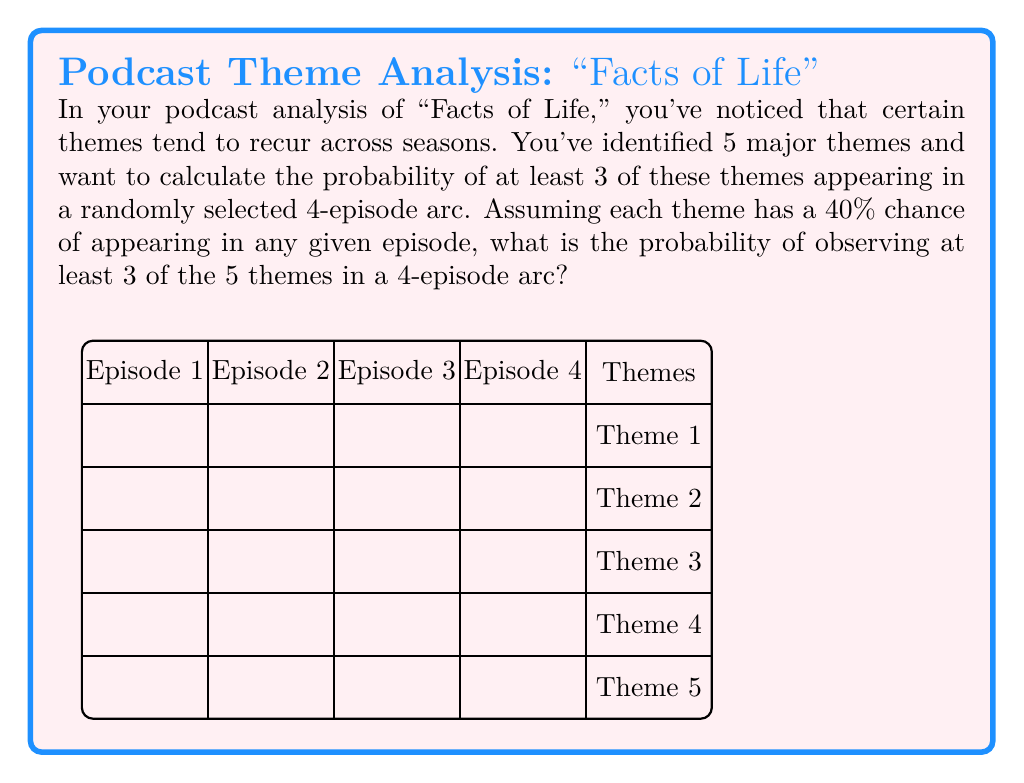Solve this math problem. Let's approach this step-by-step:

1) First, we need to calculate the probability of a single theme appearing in the 4-episode arc. The probability of a theme not appearing in an episode is 60% (1 - 40% = 60% or 0.6).

2) For a theme to not appear in the entire 4-episode arc, it must not appear in any of the 4 episodes. This probability is:

   $$(0.6)^4 = 0.1296$$

3) Therefore, the probability of a theme appearing at least once in the 4-episode arc is:

   $$1 - (0.6)^4 = 1 - 0.1296 = 0.8704$$

4) Now, we can use the binomial probability formula to calculate the probability of exactly k themes appearing out of 5, where k is 3, 4, or 5:

   $$P(X = k) = \binom{5}{k} (0.8704)^k (1-0.8704)^{5-k}$$

5) Let's calculate for k = 3, 4, and 5:

   For k = 3: $$\binom{5}{3} (0.8704)^3 (0.1296)^2 = 10 * 0.6589 * 0.0168 = 0.1107$$
   
   For k = 4: $$\binom{5}{4} (0.8704)^4 (0.1296)^1 = 5 * 0.5735 * 0.1296 = 0.3718$$
   
   For k = 5: $$\binom{5}{5} (0.8704)^5 (0.1296)^0 = 1 * 0.4992 * 1 = 0.4992$$

6) The probability of at least 3 themes appearing is the sum of these probabilities:

   $$P(X \geq 3) = 0.1107 + 0.3718 + 0.4992 = 0.9817$$
Answer: 0.9817 or approximately 98.17% 